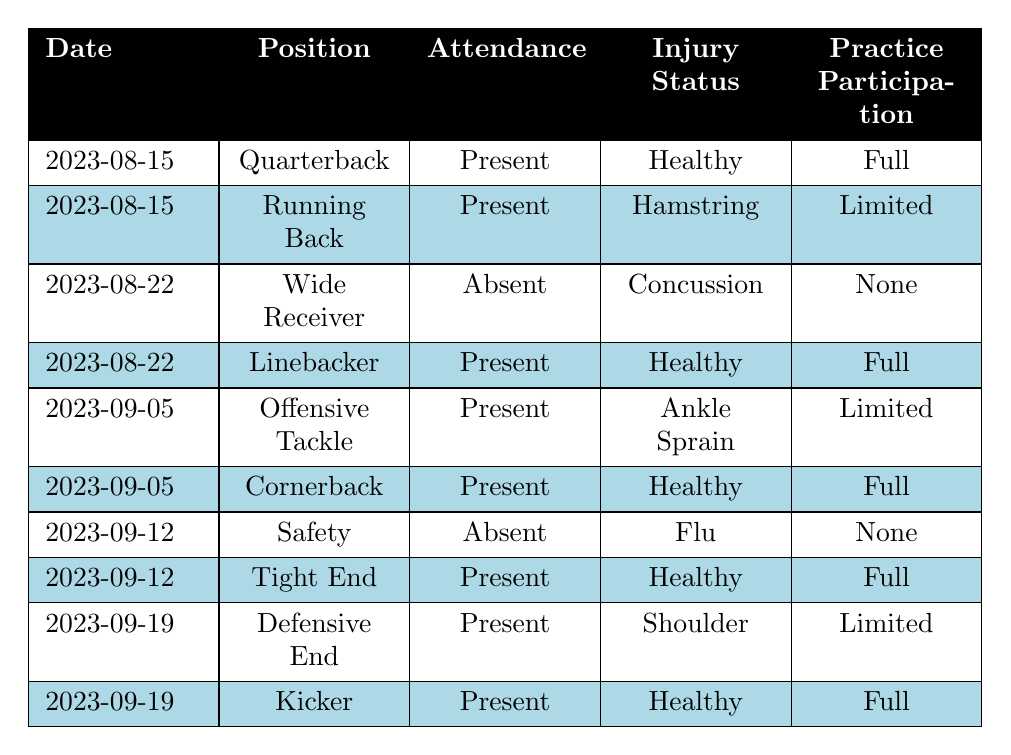What is the attendance status of Mike Johnson on 2023-08-15? Mike Johnson's attendance is specifically listed for the date 2023-08-15 in the table, where it shows that he was present at practice.
Answer: Present How many players were present in practice on 2023-09-05? There are two players listed as present on 2023-09-05: Jake Wilson and Alex Rodriguez. Simply counting the rows for that date indicates they both attended.
Answer: 2 What is the injury status of the player who attended practice on 2023-08-22? There are two players on this date: Brandon Smith, who is absent due to concussion, and Tyler Davis, who is present and healthy. The question asks for the injury status of both, so I identify Tyler Davis as attending and then note his status.
Answer: Healthy Did any player attend practice with limited participation on 2023-09-19? Kevin Brown appears on this date with limited participation, as indicated in the table. The question is specific to that date, and the table confirms his involvement.
Answer: Yes What is the total number of players who were absent throughout the recorded dates? On reviewing the table, David Lee and Brandon Smith are noted as absent. Counting these two gives us the answer for total absentees in the recorded data.
Answer: 2 Which player had a hamstring injury in practice? The table specifically identifies Chris Thompson as having a hamstring injury on 2023-08-15, when he was present but listed with a limited practice status.
Answer: Chris Thompson What is the practice participation status of the player absent on 2023-09-12? The only player absent on this date is David Lee, who is noted to have 'None' under practice participation according to the table, so this confirms his status on that date.
Answer: None Is there any player listed as having an "Ankle Sprain" injury with present attendance? Reviewing the entries, Jake Wilson on 2023-09-05 is the player marked with an ankle sprain while still being present at practice. Thus, this indicates he falls under the stated criteria.
Answer: Yes On what dates did players practice with full participation? Looking through the table, I identify players who had 'Full' under practice participation: Mike Johnson, Tyler Davis, Alex Rodriguez, Ryan Taylor, and Matt Anderson. Their associated dates are aggregated to determine all applicable practice dates.
Answer: 2023-08-15, 2023-08-22, 2023-09-05, 2023-09-12, 2023-09-19 